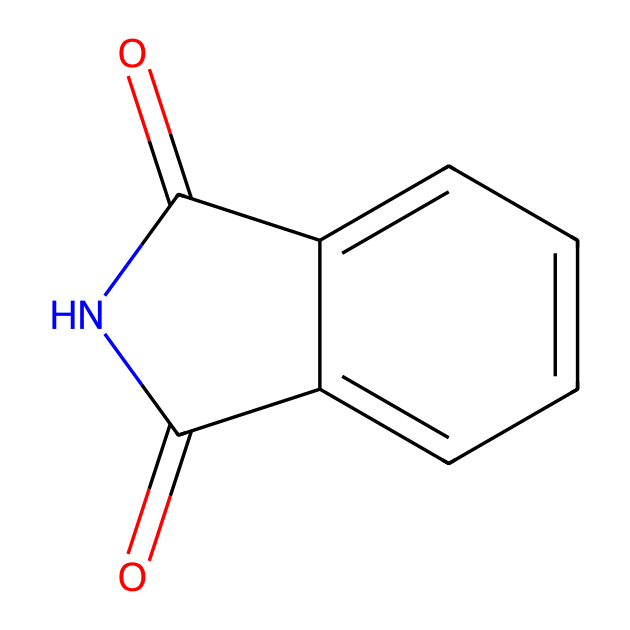What is the molecular formula of phthalimide? The molecular formula can be derived by counting the number of carbon, hydrogen, oxygen, and nitrogen atoms present in the structure based on the SMILES representation. From the structure, we identify 8 carbons (C), 5 hydrogens (H), 2 oxygens (O), and 1 nitrogen (N), leading to the formula C8H5NO2.
Answer: C8H5NO2 How many rings are present in the structure? By examining the chemical structure, it is evident that there is one ring formed by the cyclized carbon and nitrogen atoms, with an adjacent aromatic phenyl group accounted separately, leading to the identification of its singular ring structure.
Answer: 1 How many double bonds are in phthalimide? There are 3 double bonds identified in the structure: two from the carbonyl groups (C=O) and one from the nitrogen bond to carbon in the ring (C=N). Therefore, counting these gives us a total of three.
Answer: 3 What type of functional groups are present in phthalimide? The structure contains two carbonyl (C=O) groups and an amide (-C(=O)N-) functionality due to the nitrogen attached to the carbonyl, which is characteristic of imides. Therefore, the functional groups are identified as imide and carbonyl.
Answer: imide and carbonyl What type of compound is phthalimide classified as? Based on the presence of a nitrogen atom in a ring structure bonded to carbonyl groups, this compound classifies as an imide, a specific type of cyclic amide. This classification is derived from recognizing the imide structure within the chemical representation.
Answer: imide 